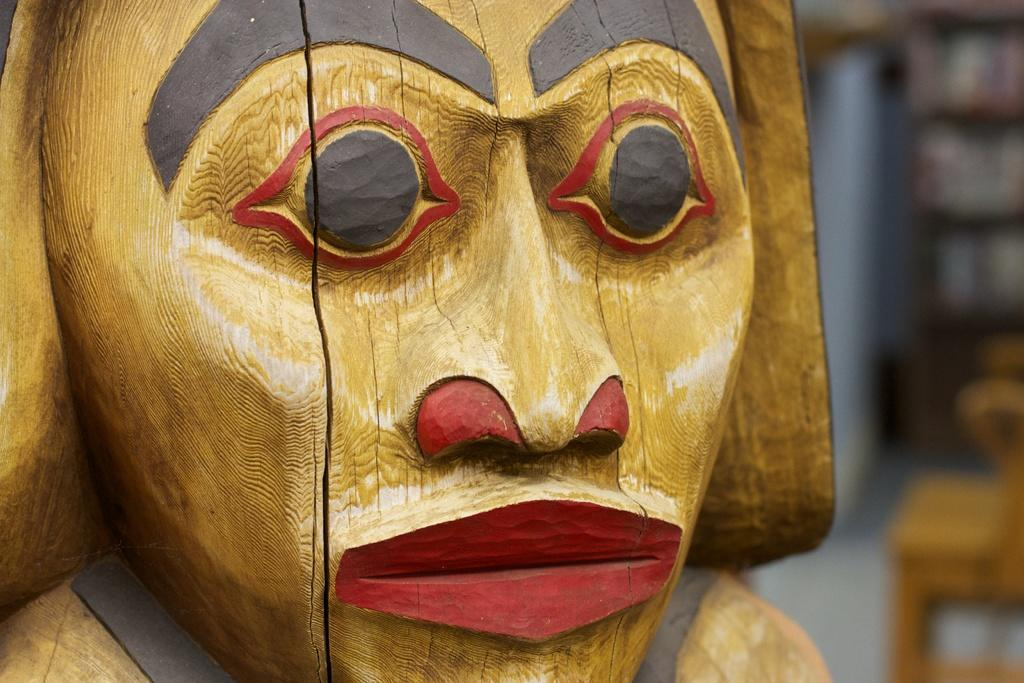What is the color of the statue in the image? The statue is in gold color. What color are the eyes of the statue? The eyes of the statue are in black color. What colors are used for the mouth and nose of the statue? The mouth and nose of the statue are in red color. How does the statue grip the oven in the image? There is no oven present in the image, and the statue is not shown gripping anything. 